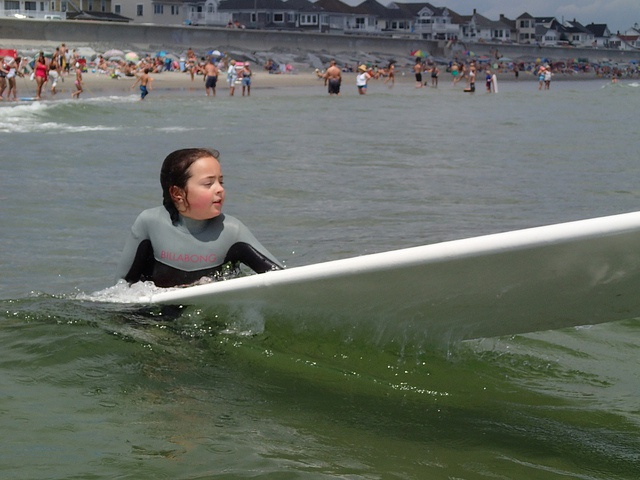Describe the objects in this image and their specific colors. I can see surfboard in gray, white, darkgreen, and darkgray tones, people in gray, black, darkgray, and brown tones, people in gray and darkgray tones, people in gray, maroon, and darkgray tones, and people in gray and black tones in this image. 